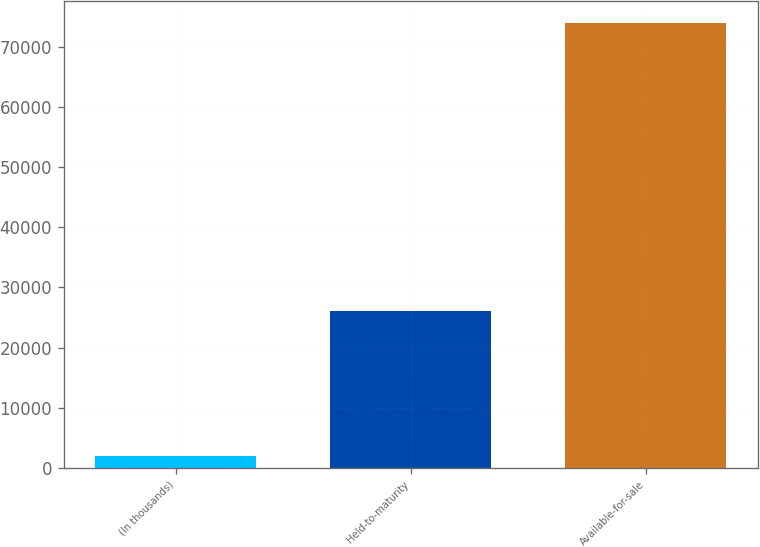<chart> <loc_0><loc_0><loc_500><loc_500><bar_chart><fcel>(In thousands)<fcel>Held-to-maturity<fcel>Available-for-sale<nl><fcel>2014<fcel>26034<fcel>73923<nl></chart> 